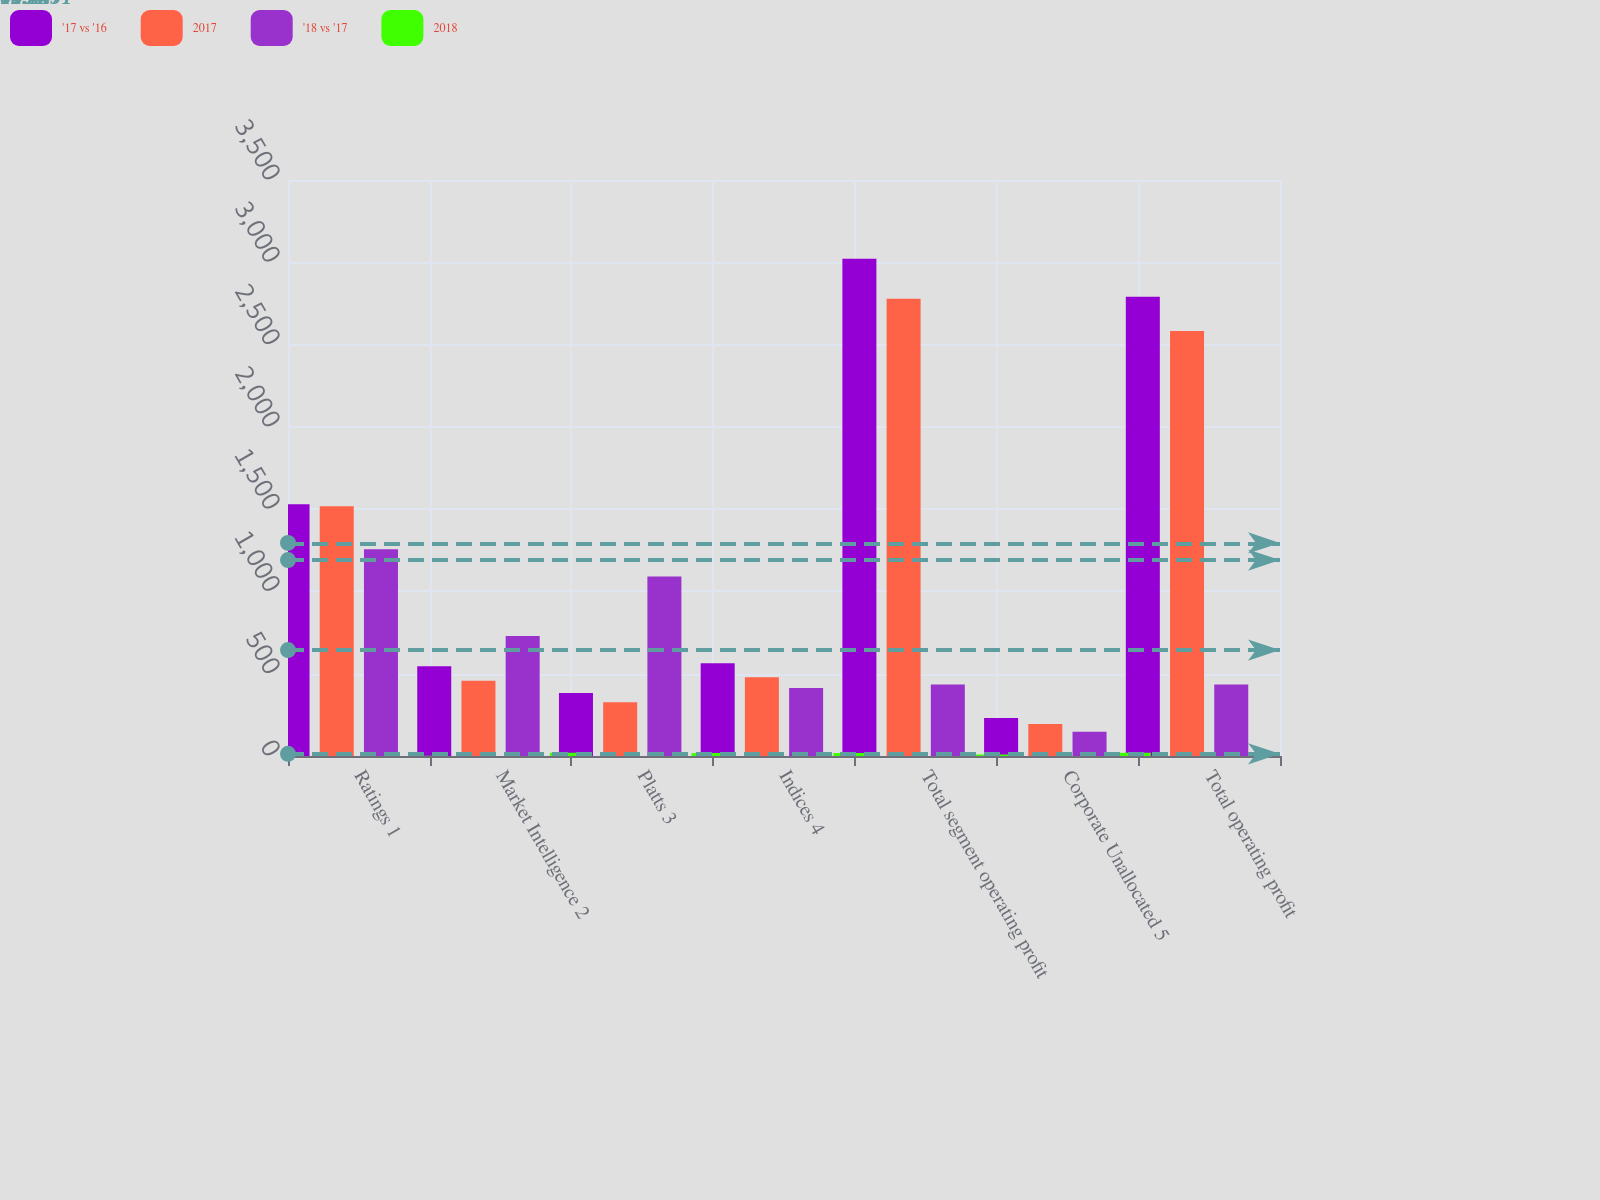Convert chart to OTSL. <chart><loc_0><loc_0><loc_500><loc_500><stacked_bar_chart><ecel><fcel>Ratings 1<fcel>Market Intelligence 2<fcel>Platts 3<fcel>Indices 4<fcel>Total segment operating profit<fcel>Corporate Unallocated 5<fcel>Total operating profit<nl><fcel>'17 vs '16<fcel>1530<fcel>545<fcel>383<fcel>563<fcel>3021<fcel>231<fcel>2790<nl><fcel>2017<fcel>1517<fcel>457<fcel>326<fcel>478<fcel>2778<fcel>195<fcel>2583<nl><fcel>'18 vs '17<fcel>1256<fcel>729<fcel>1090<fcel>413<fcel>435<fcel>147<fcel>435<nl><fcel>2018<fcel>1<fcel>19<fcel>18<fcel>18<fcel>9<fcel>19<fcel>8<nl></chart> 